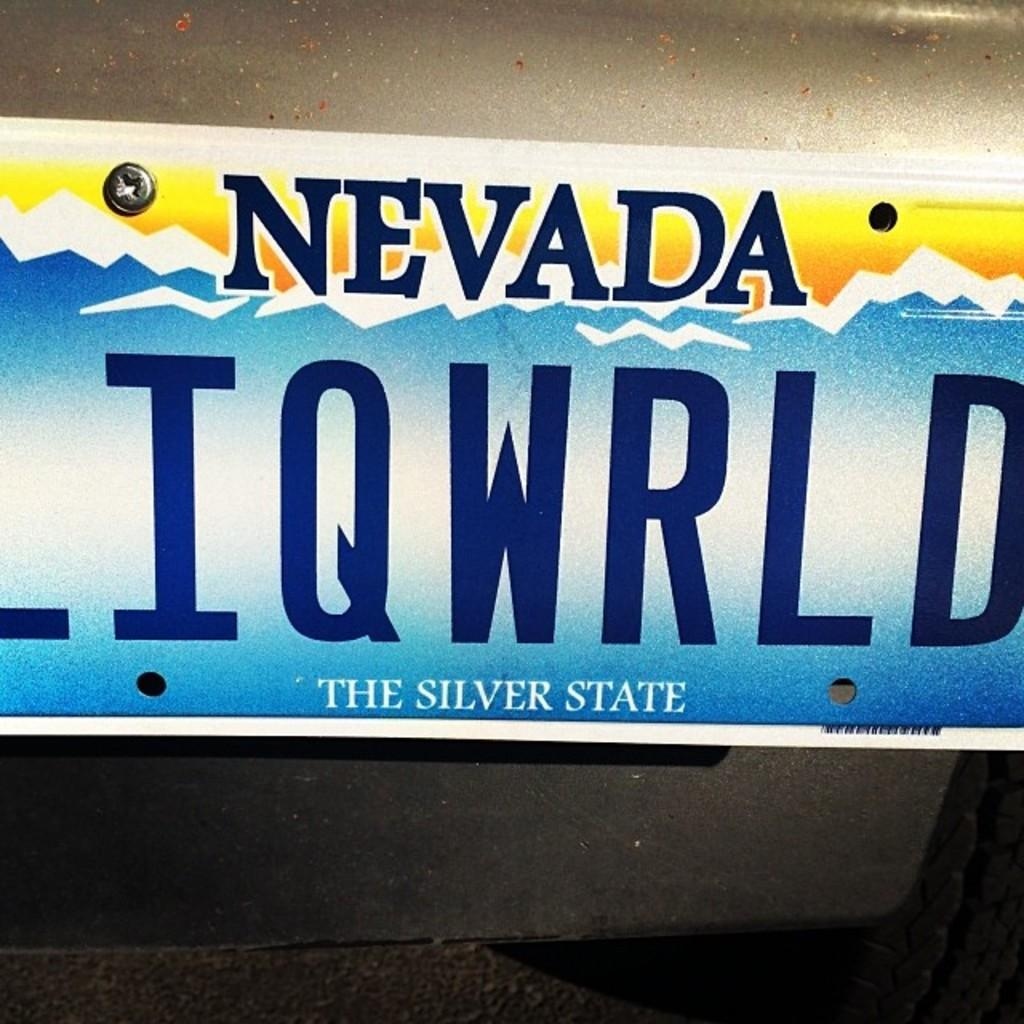<image>
Provide a brief description of the given image. A Nevada license plate says that it is The Silver State. 